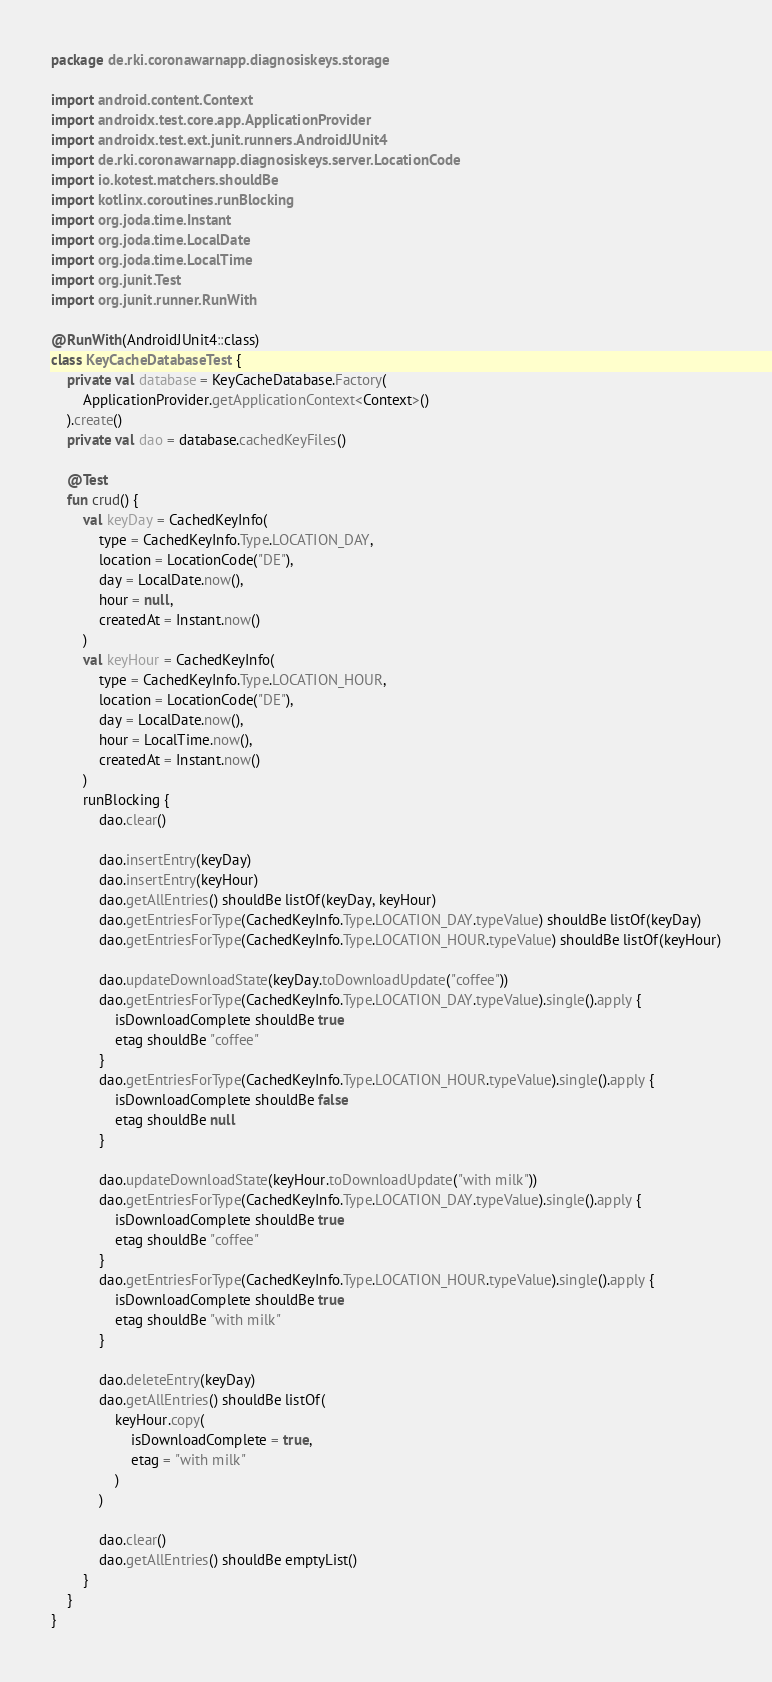Convert code to text. <code><loc_0><loc_0><loc_500><loc_500><_Kotlin_>package de.rki.coronawarnapp.diagnosiskeys.storage

import android.content.Context
import androidx.test.core.app.ApplicationProvider
import androidx.test.ext.junit.runners.AndroidJUnit4
import de.rki.coronawarnapp.diagnosiskeys.server.LocationCode
import io.kotest.matchers.shouldBe
import kotlinx.coroutines.runBlocking
import org.joda.time.Instant
import org.joda.time.LocalDate
import org.joda.time.LocalTime
import org.junit.Test
import org.junit.runner.RunWith

@RunWith(AndroidJUnit4::class)
class KeyCacheDatabaseTest {
    private val database = KeyCacheDatabase.Factory(
        ApplicationProvider.getApplicationContext<Context>()
    ).create()
    private val dao = database.cachedKeyFiles()

    @Test
    fun crud() {
        val keyDay = CachedKeyInfo(
            type = CachedKeyInfo.Type.LOCATION_DAY,
            location = LocationCode("DE"),
            day = LocalDate.now(),
            hour = null,
            createdAt = Instant.now()
        )
        val keyHour = CachedKeyInfo(
            type = CachedKeyInfo.Type.LOCATION_HOUR,
            location = LocationCode("DE"),
            day = LocalDate.now(),
            hour = LocalTime.now(),
            createdAt = Instant.now()
        )
        runBlocking {
            dao.clear()

            dao.insertEntry(keyDay)
            dao.insertEntry(keyHour)
            dao.getAllEntries() shouldBe listOf(keyDay, keyHour)
            dao.getEntriesForType(CachedKeyInfo.Type.LOCATION_DAY.typeValue) shouldBe listOf(keyDay)
            dao.getEntriesForType(CachedKeyInfo.Type.LOCATION_HOUR.typeValue) shouldBe listOf(keyHour)

            dao.updateDownloadState(keyDay.toDownloadUpdate("coffee"))
            dao.getEntriesForType(CachedKeyInfo.Type.LOCATION_DAY.typeValue).single().apply {
                isDownloadComplete shouldBe true
                etag shouldBe "coffee"
            }
            dao.getEntriesForType(CachedKeyInfo.Type.LOCATION_HOUR.typeValue).single().apply {
                isDownloadComplete shouldBe false
                etag shouldBe null
            }

            dao.updateDownloadState(keyHour.toDownloadUpdate("with milk"))
            dao.getEntriesForType(CachedKeyInfo.Type.LOCATION_DAY.typeValue).single().apply {
                isDownloadComplete shouldBe true
                etag shouldBe "coffee"
            }
            dao.getEntriesForType(CachedKeyInfo.Type.LOCATION_HOUR.typeValue).single().apply {
                isDownloadComplete shouldBe true
                etag shouldBe "with milk"
            }

            dao.deleteEntry(keyDay)
            dao.getAllEntries() shouldBe listOf(
                keyHour.copy(
                    isDownloadComplete = true,
                    etag = "with milk"
                )
            )

            dao.clear()
            dao.getAllEntries() shouldBe emptyList()
        }
    }
}
</code> 